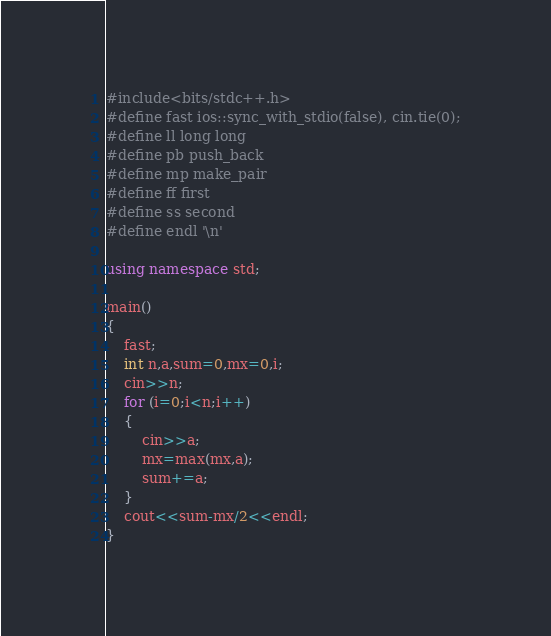<code> <loc_0><loc_0><loc_500><loc_500><_C++_>#include<bits/stdc++.h>
#define fast ios::sync_with_stdio(false), cin.tie(0);
#define ll long long
#define pb push_back
#define mp make_pair
#define ff first
#define ss second
#define endl '\n'

using namespace std;

main()
{
    fast;
    int n,a,sum=0,mx=0,i;
    cin>>n;
    for (i=0;i<n;i++)
    {
        cin>>a;
        mx=max(mx,a);
        sum+=a;
    }
    cout<<sum-mx/2<<endl;
}</code> 